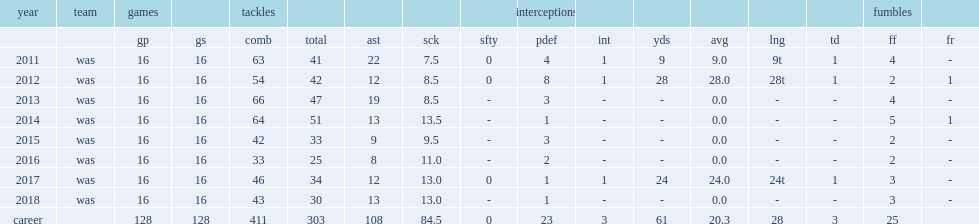How many sacks did kerrigan record in his career? 84.5. 